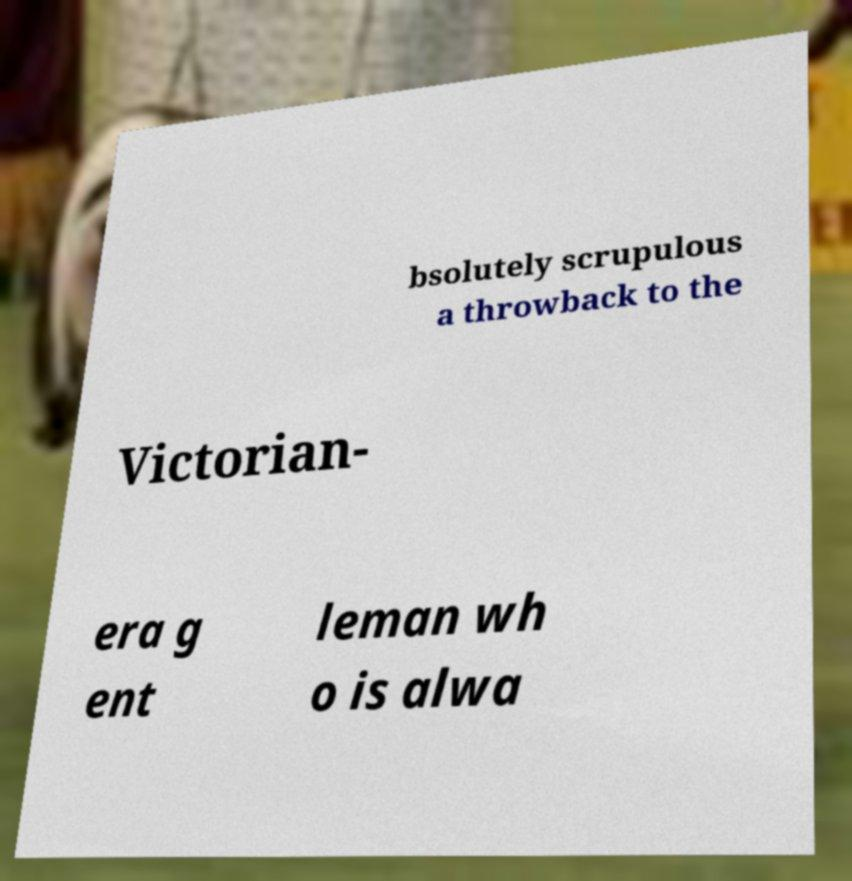Can you accurately transcribe the text from the provided image for me? bsolutely scrupulous a throwback to the Victorian- era g ent leman wh o is alwa 